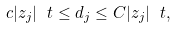<formula> <loc_0><loc_0><loc_500><loc_500>c | z _ { j } | ^ { \ } t \leq d _ { j } \leq C | z _ { j } | ^ { \ } t ,</formula> 